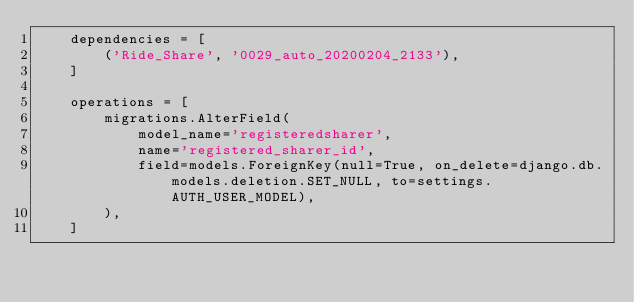<code> <loc_0><loc_0><loc_500><loc_500><_Python_>    dependencies = [
        ('Ride_Share', '0029_auto_20200204_2133'),
    ]

    operations = [
        migrations.AlterField(
            model_name='registeredsharer',
            name='registered_sharer_id',
            field=models.ForeignKey(null=True, on_delete=django.db.models.deletion.SET_NULL, to=settings.AUTH_USER_MODEL),
        ),
    ]
</code> 